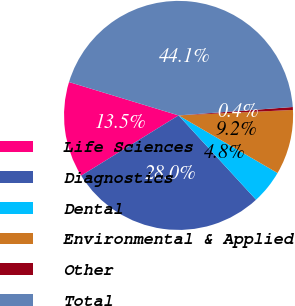<chart> <loc_0><loc_0><loc_500><loc_500><pie_chart><fcel>Life Sciences<fcel>Diagnostics<fcel>Dental<fcel>Environmental & Applied<fcel>Other<fcel>Total<nl><fcel>13.52%<fcel>28.01%<fcel>4.78%<fcel>9.15%<fcel>0.41%<fcel>44.12%<nl></chart> 